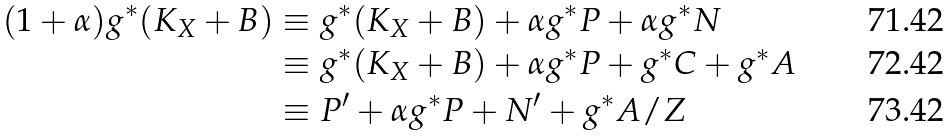<formula> <loc_0><loc_0><loc_500><loc_500>( 1 + \alpha ) g ^ { * } ( K _ { X } + B ) & \equiv g ^ { * } ( K _ { X } + B ) + \alpha g ^ { * } P + \alpha g ^ { * } N \\ & \equiv g ^ { * } ( K _ { X } + B ) + \alpha g ^ { * } P + g ^ { * } C + g ^ { * } A \\ & \equiv P ^ { \prime } + \alpha g ^ { * } P + N ^ { \prime } + g ^ { * } A / Z</formula> 